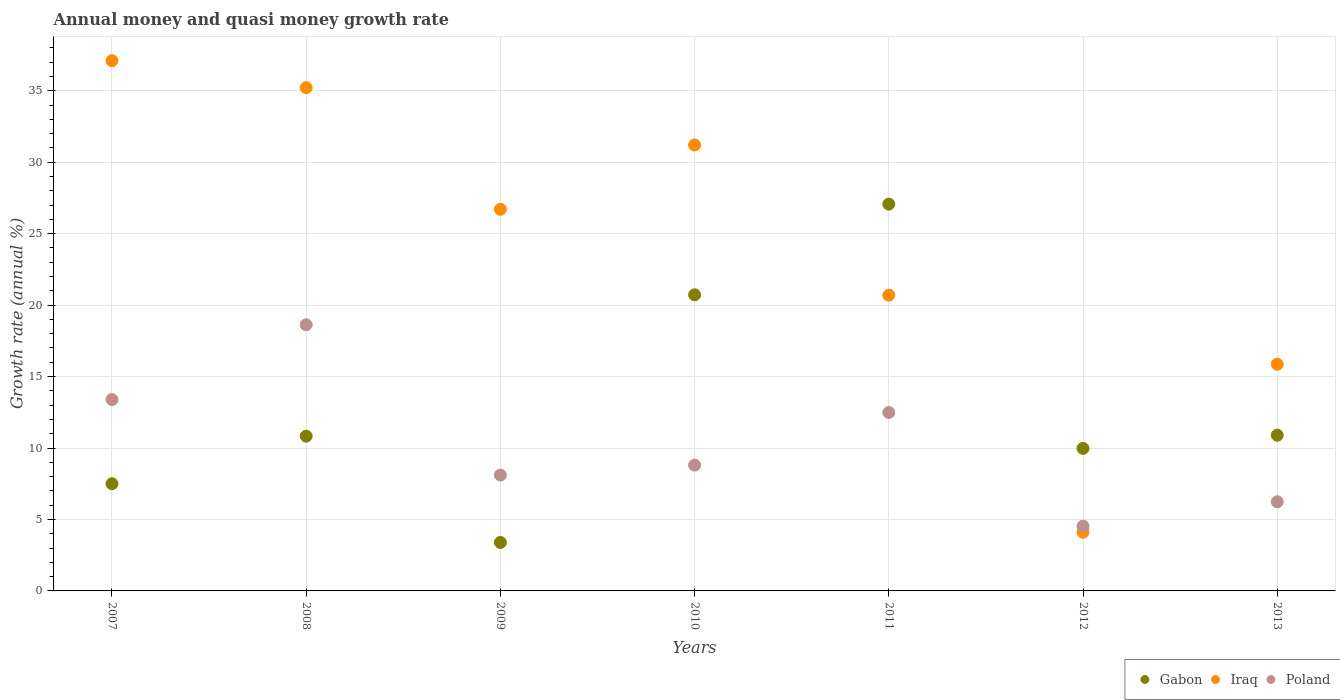What is the growth rate in Poland in 2009?
Ensure brevity in your answer.  8.11. Across all years, what is the maximum growth rate in Poland?
Give a very brief answer. 18.63. Across all years, what is the minimum growth rate in Gabon?
Make the answer very short. 3.39. What is the total growth rate in Poland in the graph?
Your answer should be very brief. 72.18. What is the difference between the growth rate in Iraq in 2010 and that in 2011?
Provide a short and direct response. 10.51. What is the difference between the growth rate in Gabon in 2013 and the growth rate in Iraq in 2012?
Your answer should be very brief. 6.79. What is the average growth rate in Poland per year?
Keep it short and to the point. 10.31. In the year 2011, what is the difference between the growth rate in Poland and growth rate in Iraq?
Give a very brief answer. -8.21. In how many years, is the growth rate in Poland greater than 18 %?
Your answer should be very brief. 1. What is the ratio of the growth rate in Iraq in 2010 to that in 2012?
Your answer should be compact. 7.6. Is the difference between the growth rate in Poland in 2008 and 2012 greater than the difference between the growth rate in Iraq in 2008 and 2012?
Keep it short and to the point. No. What is the difference between the highest and the second highest growth rate in Poland?
Your answer should be compact. 5.24. What is the difference between the highest and the lowest growth rate in Gabon?
Your response must be concise. 23.67. Is it the case that in every year, the sum of the growth rate in Gabon and growth rate in Iraq  is greater than the growth rate in Poland?
Provide a succinct answer. Yes. Is the growth rate in Poland strictly greater than the growth rate in Gabon over the years?
Provide a short and direct response. No. How many years are there in the graph?
Provide a short and direct response. 7. Are the values on the major ticks of Y-axis written in scientific E-notation?
Make the answer very short. No. Does the graph contain any zero values?
Provide a succinct answer. No. Does the graph contain grids?
Provide a succinct answer. Yes. Where does the legend appear in the graph?
Give a very brief answer. Bottom right. What is the title of the graph?
Provide a short and direct response. Annual money and quasi money growth rate. Does "Central Europe" appear as one of the legend labels in the graph?
Your answer should be compact. No. What is the label or title of the X-axis?
Your answer should be compact. Years. What is the label or title of the Y-axis?
Your answer should be very brief. Growth rate (annual %). What is the Growth rate (annual %) of Gabon in 2007?
Make the answer very short. 7.5. What is the Growth rate (annual %) of Iraq in 2007?
Keep it short and to the point. 37.11. What is the Growth rate (annual %) in Poland in 2007?
Offer a terse response. 13.39. What is the Growth rate (annual %) of Gabon in 2008?
Make the answer very short. 10.83. What is the Growth rate (annual %) of Iraq in 2008?
Offer a very short reply. 35.22. What is the Growth rate (annual %) in Poland in 2008?
Offer a terse response. 18.63. What is the Growth rate (annual %) in Gabon in 2009?
Your response must be concise. 3.39. What is the Growth rate (annual %) of Iraq in 2009?
Provide a succinct answer. 26.7. What is the Growth rate (annual %) in Poland in 2009?
Make the answer very short. 8.11. What is the Growth rate (annual %) of Gabon in 2010?
Ensure brevity in your answer.  20.72. What is the Growth rate (annual %) of Iraq in 2010?
Give a very brief answer. 31.21. What is the Growth rate (annual %) in Poland in 2010?
Your answer should be compact. 8.81. What is the Growth rate (annual %) of Gabon in 2011?
Keep it short and to the point. 27.07. What is the Growth rate (annual %) in Iraq in 2011?
Make the answer very short. 20.69. What is the Growth rate (annual %) of Poland in 2011?
Make the answer very short. 12.49. What is the Growth rate (annual %) of Gabon in 2012?
Provide a succinct answer. 9.97. What is the Growth rate (annual %) in Iraq in 2012?
Keep it short and to the point. 4.11. What is the Growth rate (annual %) in Poland in 2012?
Your answer should be very brief. 4.53. What is the Growth rate (annual %) in Gabon in 2013?
Keep it short and to the point. 10.9. What is the Growth rate (annual %) in Iraq in 2013?
Your answer should be compact. 15.86. What is the Growth rate (annual %) of Poland in 2013?
Your response must be concise. 6.24. Across all years, what is the maximum Growth rate (annual %) in Gabon?
Provide a succinct answer. 27.07. Across all years, what is the maximum Growth rate (annual %) of Iraq?
Give a very brief answer. 37.11. Across all years, what is the maximum Growth rate (annual %) in Poland?
Your answer should be compact. 18.63. Across all years, what is the minimum Growth rate (annual %) in Gabon?
Make the answer very short. 3.39. Across all years, what is the minimum Growth rate (annual %) in Iraq?
Provide a short and direct response. 4.11. Across all years, what is the minimum Growth rate (annual %) of Poland?
Ensure brevity in your answer.  4.53. What is the total Growth rate (annual %) in Gabon in the graph?
Your answer should be compact. 90.38. What is the total Growth rate (annual %) in Iraq in the graph?
Offer a very short reply. 170.9. What is the total Growth rate (annual %) in Poland in the graph?
Offer a terse response. 72.18. What is the difference between the Growth rate (annual %) of Gabon in 2007 and that in 2008?
Your answer should be very brief. -3.33. What is the difference between the Growth rate (annual %) in Iraq in 2007 and that in 2008?
Provide a succinct answer. 1.89. What is the difference between the Growth rate (annual %) in Poland in 2007 and that in 2008?
Make the answer very short. -5.24. What is the difference between the Growth rate (annual %) of Gabon in 2007 and that in 2009?
Offer a very short reply. 4.11. What is the difference between the Growth rate (annual %) of Iraq in 2007 and that in 2009?
Ensure brevity in your answer.  10.4. What is the difference between the Growth rate (annual %) of Poland in 2007 and that in 2009?
Offer a very short reply. 5.28. What is the difference between the Growth rate (annual %) in Gabon in 2007 and that in 2010?
Keep it short and to the point. -13.22. What is the difference between the Growth rate (annual %) of Iraq in 2007 and that in 2010?
Keep it short and to the point. 5.9. What is the difference between the Growth rate (annual %) in Poland in 2007 and that in 2010?
Offer a terse response. 4.58. What is the difference between the Growth rate (annual %) in Gabon in 2007 and that in 2011?
Provide a short and direct response. -19.56. What is the difference between the Growth rate (annual %) of Iraq in 2007 and that in 2011?
Offer a terse response. 16.41. What is the difference between the Growth rate (annual %) of Poland in 2007 and that in 2011?
Offer a terse response. 0.9. What is the difference between the Growth rate (annual %) of Gabon in 2007 and that in 2012?
Your answer should be compact. -2.47. What is the difference between the Growth rate (annual %) of Iraq in 2007 and that in 2012?
Offer a terse response. 33. What is the difference between the Growth rate (annual %) in Poland in 2007 and that in 2012?
Ensure brevity in your answer.  8.86. What is the difference between the Growth rate (annual %) in Gabon in 2007 and that in 2013?
Offer a terse response. -3.39. What is the difference between the Growth rate (annual %) of Iraq in 2007 and that in 2013?
Make the answer very short. 21.24. What is the difference between the Growth rate (annual %) of Poland in 2007 and that in 2013?
Keep it short and to the point. 7.15. What is the difference between the Growth rate (annual %) of Gabon in 2008 and that in 2009?
Give a very brief answer. 7.44. What is the difference between the Growth rate (annual %) in Iraq in 2008 and that in 2009?
Your response must be concise. 8.51. What is the difference between the Growth rate (annual %) of Poland in 2008 and that in 2009?
Make the answer very short. 10.52. What is the difference between the Growth rate (annual %) of Gabon in 2008 and that in 2010?
Provide a short and direct response. -9.89. What is the difference between the Growth rate (annual %) in Iraq in 2008 and that in 2010?
Make the answer very short. 4.01. What is the difference between the Growth rate (annual %) of Poland in 2008 and that in 2010?
Offer a very short reply. 9.82. What is the difference between the Growth rate (annual %) in Gabon in 2008 and that in 2011?
Provide a succinct answer. -16.23. What is the difference between the Growth rate (annual %) of Iraq in 2008 and that in 2011?
Offer a very short reply. 14.52. What is the difference between the Growth rate (annual %) of Poland in 2008 and that in 2011?
Give a very brief answer. 6.14. What is the difference between the Growth rate (annual %) in Gabon in 2008 and that in 2012?
Give a very brief answer. 0.86. What is the difference between the Growth rate (annual %) of Iraq in 2008 and that in 2012?
Offer a very short reply. 31.11. What is the difference between the Growth rate (annual %) in Poland in 2008 and that in 2012?
Provide a succinct answer. 14.1. What is the difference between the Growth rate (annual %) in Gabon in 2008 and that in 2013?
Make the answer very short. -0.07. What is the difference between the Growth rate (annual %) in Iraq in 2008 and that in 2013?
Provide a succinct answer. 19.35. What is the difference between the Growth rate (annual %) in Poland in 2008 and that in 2013?
Keep it short and to the point. 12.39. What is the difference between the Growth rate (annual %) of Gabon in 2009 and that in 2010?
Provide a succinct answer. -17.33. What is the difference between the Growth rate (annual %) in Iraq in 2009 and that in 2010?
Make the answer very short. -4.5. What is the difference between the Growth rate (annual %) in Poland in 2009 and that in 2010?
Provide a short and direct response. -0.7. What is the difference between the Growth rate (annual %) of Gabon in 2009 and that in 2011?
Keep it short and to the point. -23.67. What is the difference between the Growth rate (annual %) of Iraq in 2009 and that in 2011?
Give a very brief answer. 6.01. What is the difference between the Growth rate (annual %) of Poland in 2009 and that in 2011?
Your answer should be very brief. -4.38. What is the difference between the Growth rate (annual %) of Gabon in 2009 and that in 2012?
Offer a very short reply. -6.58. What is the difference between the Growth rate (annual %) of Iraq in 2009 and that in 2012?
Ensure brevity in your answer.  22.6. What is the difference between the Growth rate (annual %) of Poland in 2009 and that in 2012?
Your response must be concise. 3.58. What is the difference between the Growth rate (annual %) in Gabon in 2009 and that in 2013?
Offer a very short reply. -7.5. What is the difference between the Growth rate (annual %) in Iraq in 2009 and that in 2013?
Ensure brevity in your answer.  10.84. What is the difference between the Growth rate (annual %) of Poland in 2009 and that in 2013?
Your response must be concise. 1.87. What is the difference between the Growth rate (annual %) in Gabon in 2010 and that in 2011?
Your answer should be compact. -6.34. What is the difference between the Growth rate (annual %) in Iraq in 2010 and that in 2011?
Ensure brevity in your answer.  10.51. What is the difference between the Growth rate (annual %) of Poland in 2010 and that in 2011?
Your response must be concise. -3.68. What is the difference between the Growth rate (annual %) in Gabon in 2010 and that in 2012?
Your response must be concise. 10.75. What is the difference between the Growth rate (annual %) of Iraq in 2010 and that in 2012?
Your answer should be very brief. 27.1. What is the difference between the Growth rate (annual %) of Poland in 2010 and that in 2012?
Keep it short and to the point. 4.28. What is the difference between the Growth rate (annual %) of Gabon in 2010 and that in 2013?
Your response must be concise. 9.83. What is the difference between the Growth rate (annual %) in Iraq in 2010 and that in 2013?
Keep it short and to the point. 15.34. What is the difference between the Growth rate (annual %) of Poland in 2010 and that in 2013?
Keep it short and to the point. 2.57. What is the difference between the Growth rate (annual %) in Gabon in 2011 and that in 2012?
Make the answer very short. 17.09. What is the difference between the Growth rate (annual %) of Iraq in 2011 and that in 2012?
Provide a short and direct response. 16.59. What is the difference between the Growth rate (annual %) in Poland in 2011 and that in 2012?
Make the answer very short. 7.96. What is the difference between the Growth rate (annual %) in Gabon in 2011 and that in 2013?
Provide a succinct answer. 16.17. What is the difference between the Growth rate (annual %) in Iraq in 2011 and that in 2013?
Provide a short and direct response. 4.83. What is the difference between the Growth rate (annual %) in Poland in 2011 and that in 2013?
Offer a very short reply. 6.25. What is the difference between the Growth rate (annual %) in Gabon in 2012 and that in 2013?
Provide a succinct answer. -0.92. What is the difference between the Growth rate (annual %) in Iraq in 2012 and that in 2013?
Offer a very short reply. -11.75. What is the difference between the Growth rate (annual %) in Poland in 2012 and that in 2013?
Make the answer very short. -1.71. What is the difference between the Growth rate (annual %) of Gabon in 2007 and the Growth rate (annual %) of Iraq in 2008?
Your answer should be compact. -27.71. What is the difference between the Growth rate (annual %) of Gabon in 2007 and the Growth rate (annual %) of Poland in 2008?
Your answer should be very brief. -11.12. What is the difference between the Growth rate (annual %) in Iraq in 2007 and the Growth rate (annual %) in Poland in 2008?
Offer a terse response. 18.48. What is the difference between the Growth rate (annual %) of Gabon in 2007 and the Growth rate (annual %) of Iraq in 2009?
Your answer should be compact. -19.2. What is the difference between the Growth rate (annual %) in Gabon in 2007 and the Growth rate (annual %) in Poland in 2009?
Keep it short and to the point. -0.6. What is the difference between the Growth rate (annual %) in Gabon in 2007 and the Growth rate (annual %) in Iraq in 2010?
Your response must be concise. -23.7. What is the difference between the Growth rate (annual %) in Gabon in 2007 and the Growth rate (annual %) in Poland in 2010?
Offer a terse response. -1.3. What is the difference between the Growth rate (annual %) of Iraq in 2007 and the Growth rate (annual %) of Poland in 2010?
Your response must be concise. 28.3. What is the difference between the Growth rate (annual %) of Gabon in 2007 and the Growth rate (annual %) of Iraq in 2011?
Offer a terse response. -13.19. What is the difference between the Growth rate (annual %) in Gabon in 2007 and the Growth rate (annual %) in Poland in 2011?
Ensure brevity in your answer.  -4.98. What is the difference between the Growth rate (annual %) in Iraq in 2007 and the Growth rate (annual %) in Poland in 2011?
Provide a succinct answer. 24.62. What is the difference between the Growth rate (annual %) of Gabon in 2007 and the Growth rate (annual %) of Iraq in 2012?
Give a very brief answer. 3.39. What is the difference between the Growth rate (annual %) in Gabon in 2007 and the Growth rate (annual %) in Poland in 2012?
Offer a very short reply. 2.97. What is the difference between the Growth rate (annual %) in Iraq in 2007 and the Growth rate (annual %) in Poland in 2012?
Offer a terse response. 32.58. What is the difference between the Growth rate (annual %) of Gabon in 2007 and the Growth rate (annual %) of Iraq in 2013?
Offer a terse response. -8.36. What is the difference between the Growth rate (annual %) of Gabon in 2007 and the Growth rate (annual %) of Poland in 2013?
Keep it short and to the point. 1.26. What is the difference between the Growth rate (annual %) of Iraq in 2007 and the Growth rate (annual %) of Poland in 2013?
Provide a succinct answer. 30.87. What is the difference between the Growth rate (annual %) of Gabon in 2008 and the Growth rate (annual %) of Iraq in 2009?
Provide a short and direct response. -15.87. What is the difference between the Growth rate (annual %) in Gabon in 2008 and the Growth rate (annual %) in Poland in 2009?
Your response must be concise. 2.72. What is the difference between the Growth rate (annual %) in Iraq in 2008 and the Growth rate (annual %) in Poland in 2009?
Make the answer very short. 27.11. What is the difference between the Growth rate (annual %) in Gabon in 2008 and the Growth rate (annual %) in Iraq in 2010?
Provide a short and direct response. -20.38. What is the difference between the Growth rate (annual %) in Gabon in 2008 and the Growth rate (annual %) in Poland in 2010?
Your answer should be very brief. 2.02. What is the difference between the Growth rate (annual %) in Iraq in 2008 and the Growth rate (annual %) in Poland in 2010?
Keep it short and to the point. 26.41. What is the difference between the Growth rate (annual %) in Gabon in 2008 and the Growth rate (annual %) in Iraq in 2011?
Offer a very short reply. -9.86. What is the difference between the Growth rate (annual %) in Gabon in 2008 and the Growth rate (annual %) in Poland in 2011?
Give a very brief answer. -1.66. What is the difference between the Growth rate (annual %) in Iraq in 2008 and the Growth rate (annual %) in Poland in 2011?
Your answer should be very brief. 22.73. What is the difference between the Growth rate (annual %) in Gabon in 2008 and the Growth rate (annual %) in Iraq in 2012?
Give a very brief answer. 6.72. What is the difference between the Growth rate (annual %) of Gabon in 2008 and the Growth rate (annual %) of Poland in 2012?
Keep it short and to the point. 6.3. What is the difference between the Growth rate (annual %) of Iraq in 2008 and the Growth rate (annual %) of Poland in 2012?
Give a very brief answer. 30.69. What is the difference between the Growth rate (annual %) of Gabon in 2008 and the Growth rate (annual %) of Iraq in 2013?
Keep it short and to the point. -5.03. What is the difference between the Growth rate (annual %) in Gabon in 2008 and the Growth rate (annual %) in Poland in 2013?
Ensure brevity in your answer.  4.59. What is the difference between the Growth rate (annual %) of Iraq in 2008 and the Growth rate (annual %) of Poland in 2013?
Ensure brevity in your answer.  28.98. What is the difference between the Growth rate (annual %) of Gabon in 2009 and the Growth rate (annual %) of Iraq in 2010?
Offer a very short reply. -27.81. What is the difference between the Growth rate (annual %) in Gabon in 2009 and the Growth rate (annual %) in Poland in 2010?
Your response must be concise. -5.41. What is the difference between the Growth rate (annual %) in Iraq in 2009 and the Growth rate (annual %) in Poland in 2010?
Keep it short and to the point. 17.9. What is the difference between the Growth rate (annual %) in Gabon in 2009 and the Growth rate (annual %) in Iraq in 2011?
Keep it short and to the point. -17.3. What is the difference between the Growth rate (annual %) of Gabon in 2009 and the Growth rate (annual %) of Poland in 2011?
Make the answer very short. -9.09. What is the difference between the Growth rate (annual %) of Iraq in 2009 and the Growth rate (annual %) of Poland in 2011?
Provide a succinct answer. 14.22. What is the difference between the Growth rate (annual %) in Gabon in 2009 and the Growth rate (annual %) in Iraq in 2012?
Keep it short and to the point. -0.72. What is the difference between the Growth rate (annual %) in Gabon in 2009 and the Growth rate (annual %) in Poland in 2012?
Your response must be concise. -1.13. What is the difference between the Growth rate (annual %) in Iraq in 2009 and the Growth rate (annual %) in Poland in 2012?
Make the answer very short. 22.18. What is the difference between the Growth rate (annual %) in Gabon in 2009 and the Growth rate (annual %) in Iraq in 2013?
Make the answer very short. -12.47. What is the difference between the Growth rate (annual %) in Gabon in 2009 and the Growth rate (annual %) in Poland in 2013?
Your answer should be compact. -2.85. What is the difference between the Growth rate (annual %) of Iraq in 2009 and the Growth rate (annual %) of Poland in 2013?
Offer a very short reply. 20.46. What is the difference between the Growth rate (annual %) of Gabon in 2010 and the Growth rate (annual %) of Iraq in 2011?
Make the answer very short. 0.03. What is the difference between the Growth rate (annual %) in Gabon in 2010 and the Growth rate (annual %) in Poland in 2011?
Keep it short and to the point. 8.24. What is the difference between the Growth rate (annual %) of Iraq in 2010 and the Growth rate (annual %) of Poland in 2011?
Offer a very short reply. 18.72. What is the difference between the Growth rate (annual %) of Gabon in 2010 and the Growth rate (annual %) of Iraq in 2012?
Provide a succinct answer. 16.61. What is the difference between the Growth rate (annual %) of Gabon in 2010 and the Growth rate (annual %) of Poland in 2012?
Your answer should be compact. 16.19. What is the difference between the Growth rate (annual %) in Iraq in 2010 and the Growth rate (annual %) in Poland in 2012?
Offer a very short reply. 26.68. What is the difference between the Growth rate (annual %) in Gabon in 2010 and the Growth rate (annual %) in Iraq in 2013?
Make the answer very short. 4.86. What is the difference between the Growth rate (annual %) of Gabon in 2010 and the Growth rate (annual %) of Poland in 2013?
Provide a short and direct response. 14.48. What is the difference between the Growth rate (annual %) of Iraq in 2010 and the Growth rate (annual %) of Poland in 2013?
Offer a terse response. 24.97. What is the difference between the Growth rate (annual %) in Gabon in 2011 and the Growth rate (annual %) in Iraq in 2012?
Provide a succinct answer. 22.96. What is the difference between the Growth rate (annual %) of Gabon in 2011 and the Growth rate (annual %) of Poland in 2012?
Your answer should be very brief. 22.54. What is the difference between the Growth rate (annual %) in Iraq in 2011 and the Growth rate (annual %) in Poland in 2012?
Offer a terse response. 16.17. What is the difference between the Growth rate (annual %) of Gabon in 2011 and the Growth rate (annual %) of Iraq in 2013?
Your response must be concise. 11.2. What is the difference between the Growth rate (annual %) of Gabon in 2011 and the Growth rate (annual %) of Poland in 2013?
Offer a terse response. 20.83. What is the difference between the Growth rate (annual %) in Iraq in 2011 and the Growth rate (annual %) in Poland in 2013?
Offer a very short reply. 14.46. What is the difference between the Growth rate (annual %) of Gabon in 2012 and the Growth rate (annual %) of Iraq in 2013?
Keep it short and to the point. -5.89. What is the difference between the Growth rate (annual %) of Gabon in 2012 and the Growth rate (annual %) of Poland in 2013?
Provide a short and direct response. 3.73. What is the difference between the Growth rate (annual %) of Iraq in 2012 and the Growth rate (annual %) of Poland in 2013?
Give a very brief answer. -2.13. What is the average Growth rate (annual %) of Gabon per year?
Ensure brevity in your answer.  12.91. What is the average Growth rate (annual %) of Iraq per year?
Ensure brevity in your answer.  24.41. What is the average Growth rate (annual %) in Poland per year?
Offer a terse response. 10.31. In the year 2007, what is the difference between the Growth rate (annual %) of Gabon and Growth rate (annual %) of Iraq?
Your answer should be very brief. -29.6. In the year 2007, what is the difference between the Growth rate (annual %) in Gabon and Growth rate (annual %) in Poland?
Give a very brief answer. -5.89. In the year 2007, what is the difference between the Growth rate (annual %) of Iraq and Growth rate (annual %) of Poland?
Provide a short and direct response. 23.72. In the year 2008, what is the difference between the Growth rate (annual %) in Gabon and Growth rate (annual %) in Iraq?
Your answer should be very brief. -24.39. In the year 2008, what is the difference between the Growth rate (annual %) in Gabon and Growth rate (annual %) in Poland?
Provide a succinct answer. -7.8. In the year 2008, what is the difference between the Growth rate (annual %) of Iraq and Growth rate (annual %) of Poland?
Make the answer very short. 16.59. In the year 2009, what is the difference between the Growth rate (annual %) of Gabon and Growth rate (annual %) of Iraq?
Offer a terse response. -23.31. In the year 2009, what is the difference between the Growth rate (annual %) of Gabon and Growth rate (annual %) of Poland?
Your answer should be very brief. -4.71. In the year 2009, what is the difference between the Growth rate (annual %) of Iraq and Growth rate (annual %) of Poland?
Provide a succinct answer. 18.6. In the year 2010, what is the difference between the Growth rate (annual %) of Gabon and Growth rate (annual %) of Iraq?
Make the answer very short. -10.48. In the year 2010, what is the difference between the Growth rate (annual %) in Gabon and Growth rate (annual %) in Poland?
Offer a very short reply. 11.92. In the year 2010, what is the difference between the Growth rate (annual %) in Iraq and Growth rate (annual %) in Poland?
Ensure brevity in your answer.  22.4. In the year 2011, what is the difference between the Growth rate (annual %) of Gabon and Growth rate (annual %) of Iraq?
Provide a succinct answer. 6.37. In the year 2011, what is the difference between the Growth rate (annual %) of Gabon and Growth rate (annual %) of Poland?
Your answer should be compact. 14.58. In the year 2011, what is the difference between the Growth rate (annual %) in Iraq and Growth rate (annual %) in Poland?
Your answer should be very brief. 8.21. In the year 2012, what is the difference between the Growth rate (annual %) in Gabon and Growth rate (annual %) in Iraq?
Give a very brief answer. 5.87. In the year 2012, what is the difference between the Growth rate (annual %) in Gabon and Growth rate (annual %) in Poland?
Offer a very short reply. 5.45. In the year 2012, what is the difference between the Growth rate (annual %) in Iraq and Growth rate (annual %) in Poland?
Your answer should be very brief. -0.42. In the year 2013, what is the difference between the Growth rate (annual %) in Gabon and Growth rate (annual %) in Iraq?
Offer a terse response. -4.97. In the year 2013, what is the difference between the Growth rate (annual %) in Gabon and Growth rate (annual %) in Poland?
Give a very brief answer. 4.66. In the year 2013, what is the difference between the Growth rate (annual %) of Iraq and Growth rate (annual %) of Poland?
Provide a short and direct response. 9.62. What is the ratio of the Growth rate (annual %) of Gabon in 2007 to that in 2008?
Your answer should be compact. 0.69. What is the ratio of the Growth rate (annual %) of Iraq in 2007 to that in 2008?
Provide a short and direct response. 1.05. What is the ratio of the Growth rate (annual %) in Poland in 2007 to that in 2008?
Your answer should be very brief. 0.72. What is the ratio of the Growth rate (annual %) in Gabon in 2007 to that in 2009?
Offer a very short reply. 2.21. What is the ratio of the Growth rate (annual %) of Iraq in 2007 to that in 2009?
Offer a terse response. 1.39. What is the ratio of the Growth rate (annual %) in Poland in 2007 to that in 2009?
Keep it short and to the point. 1.65. What is the ratio of the Growth rate (annual %) of Gabon in 2007 to that in 2010?
Offer a very short reply. 0.36. What is the ratio of the Growth rate (annual %) in Iraq in 2007 to that in 2010?
Offer a terse response. 1.19. What is the ratio of the Growth rate (annual %) in Poland in 2007 to that in 2010?
Offer a very short reply. 1.52. What is the ratio of the Growth rate (annual %) in Gabon in 2007 to that in 2011?
Make the answer very short. 0.28. What is the ratio of the Growth rate (annual %) of Iraq in 2007 to that in 2011?
Ensure brevity in your answer.  1.79. What is the ratio of the Growth rate (annual %) of Poland in 2007 to that in 2011?
Offer a terse response. 1.07. What is the ratio of the Growth rate (annual %) in Gabon in 2007 to that in 2012?
Keep it short and to the point. 0.75. What is the ratio of the Growth rate (annual %) in Iraq in 2007 to that in 2012?
Your response must be concise. 9.03. What is the ratio of the Growth rate (annual %) in Poland in 2007 to that in 2012?
Your response must be concise. 2.96. What is the ratio of the Growth rate (annual %) of Gabon in 2007 to that in 2013?
Give a very brief answer. 0.69. What is the ratio of the Growth rate (annual %) of Iraq in 2007 to that in 2013?
Keep it short and to the point. 2.34. What is the ratio of the Growth rate (annual %) of Poland in 2007 to that in 2013?
Offer a terse response. 2.15. What is the ratio of the Growth rate (annual %) in Gabon in 2008 to that in 2009?
Provide a short and direct response. 3.19. What is the ratio of the Growth rate (annual %) of Iraq in 2008 to that in 2009?
Your answer should be compact. 1.32. What is the ratio of the Growth rate (annual %) in Poland in 2008 to that in 2009?
Give a very brief answer. 2.3. What is the ratio of the Growth rate (annual %) in Gabon in 2008 to that in 2010?
Your answer should be very brief. 0.52. What is the ratio of the Growth rate (annual %) in Iraq in 2008 to that in 2010?
Provide a short and direct response. 1.13. What is the ratio of the Growth rate (annual %) in Poland in 2008 to that in 2010?
Offer a terse response. 2.12. What is the ratio of the Growth rate (annual %) of Gabon in 2008 to that in 2011?
Your response must be concise. 0.4. What is the ratio of the Growth rate (annual %) of Iraq in 2008 to that in 2011?
Make the answer very short. 1.7. What is the ratio of the Growth rate (annual %) of Poland in 2008 to that in 2011?
Your answer should be compact. 1.49. What is the ratio of the Growth rate (annual %) in Gabon in 2008 to that in 2012?
Provide a succinct answer. 1.09. What is the ratio of the Growth rate (annual %) of Iraq in 2008 to that in 2012?
Give a very brief answer. 8.57. What is the ratio of the Growth rate (annual %) in Poland in 2008 to that in 2012?
Give a very brief answer. 4.11. What is the ratio of the Growth rate (annual %) of Iraq in 2008 to that in 2013?
Ensure brevity in your answer.  2.22. What is the ratio of the Growth rate (annual %) in Poland in 2008 to that in 2013?
Offer a terse response. 2.99. What is the ratio of the Growth rate (annual %) in Gabon in 2009 to that in 2010?
Make the answer very short. 0.16. What is the ratio of the Growth rate (annual %) in Iraq in 2009 to that in 2010?
Ensure brevity in your answer.  0.86. What is the ratio of the Growth rate (annual %) of Poland in 2009 to that in 2010?
Provide a short and direct response. 0.92. What is the ratio of the Growth rate (annual %) in Gabon in 2009 to that in 2011?
Give a very brief answer. 0.13. What is the ratio of the Growth rate (annual %) in Iraq in 2009 to that in 2011?
Make the answer very short. 1.29. What is the ratio of the Growth rate (annual %) in Poland in 2009 to that in 2011?
Give a very brief answer. 0.65. What is the ratio of the Growth rate (annual %) in Gabon in 2009 to that in 2012?
Offer a terse response. 0.34. What is the ratio of the Growth rate (annual %) of Poland in 2009 to that in 2012?
Provide a succinct answer. 1.79. What is the ratio of the Growth rate (annual %) in Gabon in 2009 to that in 2013?
Give a very brief answer. 0.31. What is the ratio of the Growth rate (annual %) in Iraq in 2009 to that in 2013?
Give a very brief answer. 1.68. What is the ratio of the Growth rate (annual %) in Poland in 2009 to that in 2013?
Your response must be concise. 1.3. What is the ratio of the Growth rate (annual %) of Gabon in 2010 to that in 2011?
Your answer should be compact. 0.77. What is the ratio of the Growth rate (annual %) in Iraq in 2010 to that in 2011?
Your response must be concise. 1.51. What is the ratio of the Growth rate (annual %) in Poland in 2010 to that in 2011?
Your answer should be compact. 0.71. What is the ratio of the Growth rate (annual %) in Gabon in 2010 to that in 2012?
Your answer should be very brief. 2.08. What is the ratio of the Growth rate (annual %) in Iraq in 2010 to that in 2012?
Provide a succinct answer. 7.6. What is the ratio of the Growth rate (annual %) of Poland in 2010 to that in 2012?
Your response must be concise. 1.94. What is the ratio of the Growth rate (annual %) of Gabon in 2010 to that in 2013?
Make the answer very short. 1.9. What is the ratio of the Growth rate (annual %) in Iraq in 2010 to that in 2013?
Keep it short and to the point. 1.97. What is the ratio of the Growth rate (annual %) of Poland in 2010 to that in 2013?
Keep it short and to the point. 1.41. What is the ratio of the Growth rate (annual %) in Gabon in 2011 to that in 2012?
Give a very brief answer. 2.71. What is the ratio of the Growth rate (annual %) of Iraq in 2011 to that in 2012?
Provide a short and direct response. 5.04. What is the ratio of the Growth rate (annual %) in Poland in 2011 to that in 2012?
Give a very brief answer. 2.76. What is the ratio of the Growth rate (annual %) of Gabon in 2011 to that in 2013?
Your answer should be very brief. 2.48. What is the ratio of the Growth rate (annual %) in Iraq in 2011 to that in 2013?
Provide a succinct answer. 1.3. What is the ratio of the Growth rate (annual %) of Poland in 2011 to that in 2013?
Give a very brief answer. 2. What is the ratio of the Growth rate (annual %) of Gabon in 2012 to that in 2013?
Make the answer very short. 0.92. What is the ratio of the Growth rate (annual %) in Iraq in 2012 to that in 2013?
Your response must be concise. 0.26. What is the ratio of the Growth rate (annual %) of Poland in 2012 to that in 2013?
Offer a very short reply. 0.73. What is the difference between the highest and the second highest Growth rate (annual %) of Gabon?
Your answer should be very brief. 6.34. What is the difference between the highest and the second highest Growth rate (annual %) in Iraq?
Provide a short and direct response. 1.89. What is the difference between the highest and the second highest Growth rate (annual %) of Poland?
Offer a very short reply. 5.24. What is the difference between the highest and the lowest Growth rate (annual %) of Gabon?
Your answer should be compact. 23.67. What is the difference between the highest and the lowest Growth rate (annual %) of Iraq?
Keep it short and to the point. 33. What is the difference between the highest and the lowest Growth rate (annual %) of Poland?
Your response must be concise. 14.1. 